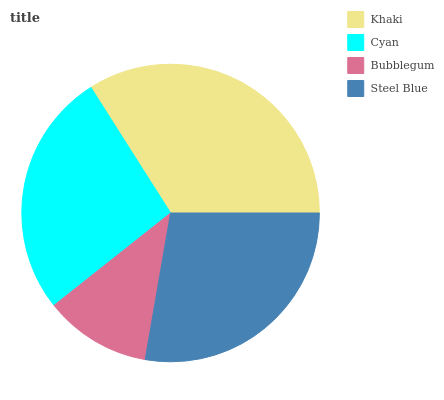Is Bubblegum the minimum?
Answer yes or no. Yes. Is Khaki the maximum?
Answer yes or no. Yes. Is Cyan the minimum?
Answer yes or no. No. Is Cyan the maximum?
Answer yes or no. No. Is Khaki greater than Cyan?
Answer yes or no. Yes. Is Cyan less than Khaki?
Answer yes or no. Yes. Is Cyan greater than Khaki?
Answer yes or no. No. Is Khaki less than Cyan?
Answer yes or no. No. Is Steel Blue the high median?
Answer yes or no. Yes. Is Cyan the low median?
Answer yes or no. Yes. Is Bubblegum the high median?
Answer yes or no. No. Is Bubblegum the low median?
Answer yes or no. No. 